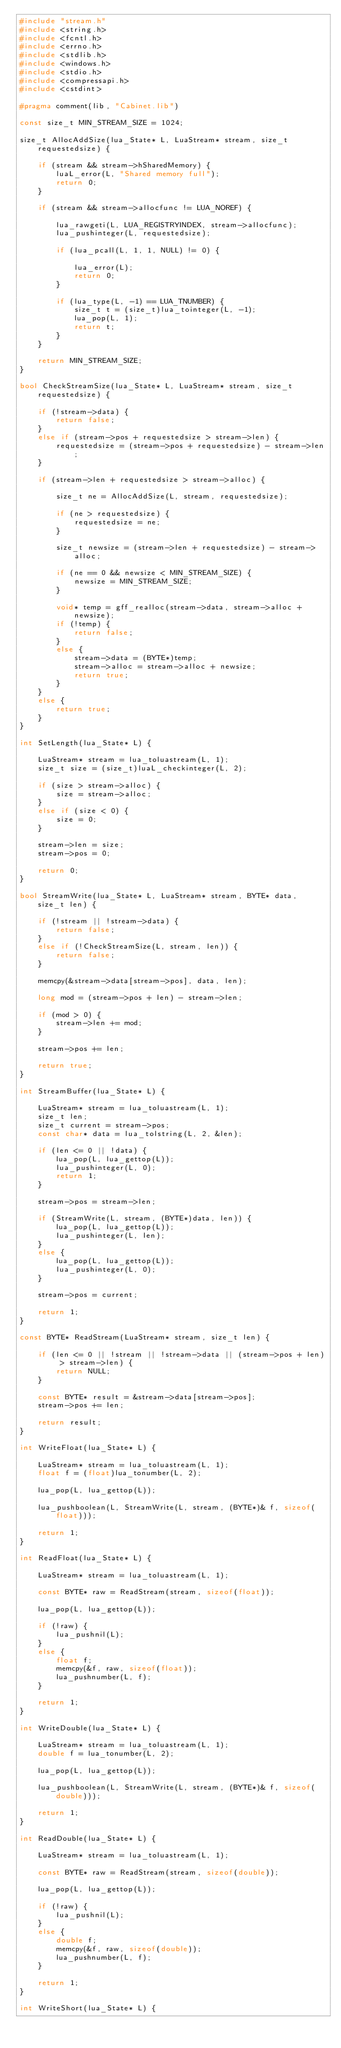Convert code to text. <code><loc_0><loc_0><loc_500><loc_500><_C++_>#include "stream.h"
#include <string.h>
#include <fcntl.h>
#include <errno.h>
#include <stdlib.h> 
#include <windows.h> 
#include <stdio.h>
#include <compressapi.h>
#include <cstdint>

#pragma comment(lib, "Cabinet.lib")

const size_t MIN_STREAM_SIZE = 1024;

size_t AllocAddSize(lua_State* L, LuaStream* stream, size_t requestedsize) {

	if (stream && stream->hSharedMemory) {
		luaL_error(L, "Shared memory full");
		return 0;
	}

	if (stream && stream->allocfunc != LUA_NOREF) {

		lua_rawgeti(L, LUA_REGISTRYINDEX, stream->allocfunc);
		lua_pushinteger(L, requestedsize);

		if (lua_pcall(L, 1, 1, NULL) != 0) {

			lua_error(L);
			return 0;
		}

		if (lua_type(L, -1) == LUA_TNUMBER) {
			size_t t = (size_t)lua_tointeger(L, -1);
			lua_pop(L, 1);
			return t;
		}
	}

	return MIN_STREAM_SIZE;
}

bool CheckStreamSize(lua_State* L, LuaStream* stream, size_t requestedsize) {

	if (!stream->data) {
		return false;
	}
	else if (stream->pos + requestedsize > stream->len) {
		requestedsize = (stream->pos + requestedsize) - stream->len;
	}

	if (stream->len + requestedsize > stream->alloc) {

		size_t ne = AllocAddSize(L, stream, requestedsize);

		if (ne > requestedsize) {
			requestedsize = ne;
		}

		size_t newsize = (stream->len + requestedsize) - stream->alloc;

		if (ne == 0 && newsize < MIN_STREAM_SIZE) {
			newsize = MIN_STREAM_SIZE;
		}

		void* temp = gff_realloc(stream->data, stream->alloc + newsize);
		if (!temp) {
			return false;
		}
		else {
			stream->data = (BYTE*)temp;
			stream->alloc = stream->alloc + newsize;
			return true;
		}
	}
	else {
		return true;
	}
}

int SetLength(lua_State* L) {

	LuaStream* stream = lua_toluastream(L, 1);
	size_t size = (size_t)luaL_checkinteger(L, 2);

	if (size > stream->alloc) {
		size = stream->alloc;
	}
	else if (size < 0) {
		size = 0;
	}

	stream->len = size;
	stream->pos = 0;

	return 0;
}

bool StreamWrite(lua_State* L, LuaStream* stream, BYTE* data, size_t len) {

	if (!stream || !stream->data) {
		return false;
	}
	else if (!CheckStreamSize(L, stream, len)) {
		return false;
	}

	memcpy(&stream->data[stream->pos], data, len);

	long mod = (stream->pos + len) - stream->len;

	if (mod > 0) {
		stream->len += mod;
	}

	stream->pos += len;

	return true;
}

int StreamBuffer(lua_State* L) {

	LuaStream* stream = lua_toluastream(L, 1);
	size_t len;
	size_t current = stream->pos;
	const char* data = lua_tolstring(L, 2, &len);

	if (len <= 0 || !data) {
		lua_pop(L, lua_gettop(L));
		lua_pushinteger(L, 0);
		return 1;
	}

	stream->pos = stream->len;

	if (StreamWrite(L, stream, (BYTE*)data, len)) {
		lua_pop(L, lua_gettop(L));
		lua_pushinteger(L, len);
	}
	else {
		lua_pop(L, lua_gettop(L));
		lua_pushinteger(L, 0);
	}

	stream->pos = current;

	return 1;
}

const BYTE* ReadStream(LuaStream* stream, size_t len) {

	if (len <= 0 || !stream || !stream->data || (stream->pos + len) > stream->len) {
		return NULL;
	}

	const BYTE* result = &stream->data[stream->pos];
	stream->pos += len;

	return result;
}

int WriteFloat(lua_State* L) {

	LuaStream* stream = lua_toluastream(L, 1);
	float f = (float)lua_tonumber(L, 2);

	lua_pop(L, lua_gettop(L));

	lua_pushboolean(L, StreamWrite(L, stream, (BYTE*)& f, sizeof(float)));

	return 1;
}

int ReadFloat(lua_State* L) {

	LuaStream* stream = lua_toluastream(L, 1);

	const BYTE* raw = ReadStream(stream, sizeof(float));

	lua_pop(L, lua_gettop(L));

	if (!raw) {
		lua_pushnil(L);
	}
	else {
		float f;
		memcpy(&f, raw, sizeof(float));
		lua_pushnumber(L, f);
	}

	return 1;
}

int WriteDouble(lua_State* L) {

	LuaStream* stream = lua_toluastream(L, 1);
	double f = lua_tonumber(L, 2);

	lua_pop(L, lua_gettop(L));

	lua_pushboolean(L, StreamWrite(L, stream, (BYTE*)& f, sizeof(double)));

	return 1;
}

int ReadDouble(lua_State* L) {

	LuaStream* stream = lua_toluastream(L, 1);

	const BYTE* raw = ReadStream(stream, sizeof(double));

	lua_pop(L, lua_gettop(L));

	if (!raw) {
		lua_pushnil(L);
	}
	else {
		double f;
		memcpy(&f, raw, sizeof(double));
		lua_pushnumber(L, f);
	}

	return 1;
}

int WriteShort(lua_State* L) {
</code> 